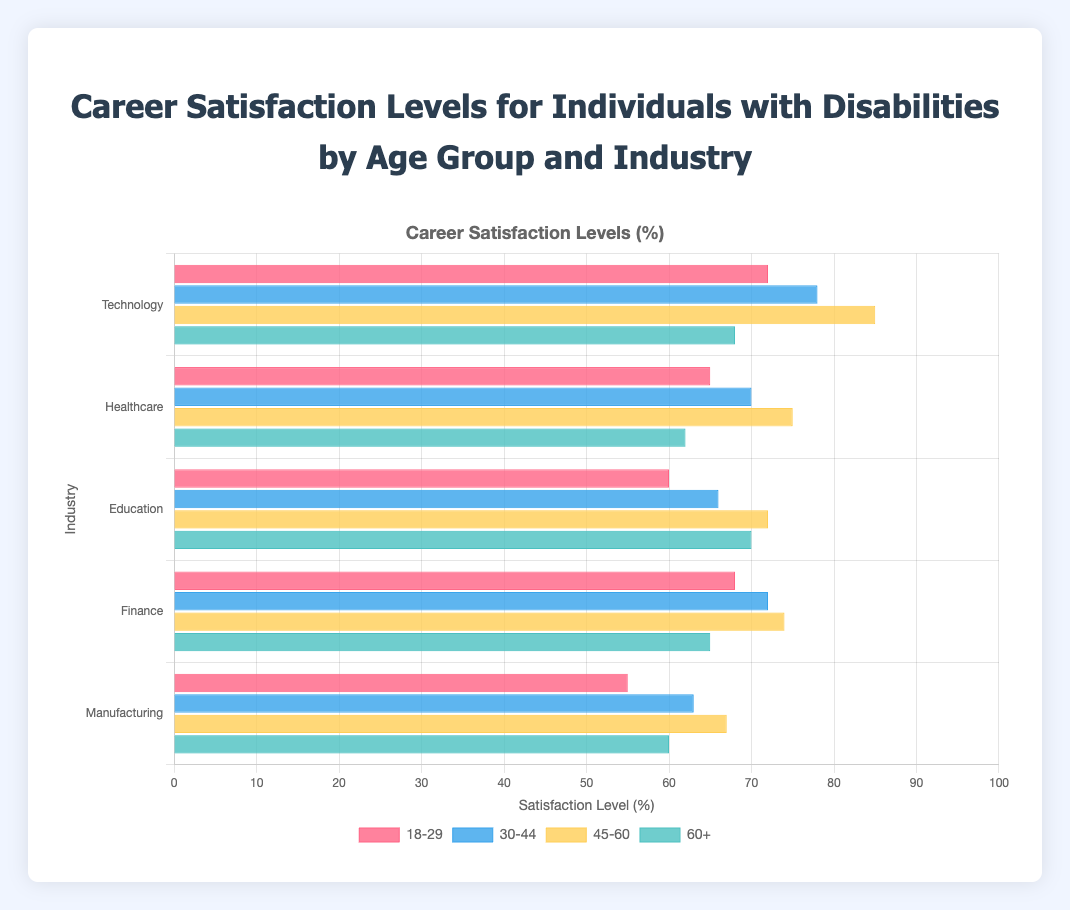Which industry has the highest career satisfaction for the age group 45-60? The bar corresponding to the 45-60 age group for the Technology industry is the tallest, showing the highest satisfaction at 85.
Answer: Technology Comparing the age groups 18-29 and 30-44, which one has higher satisfaction in the Healthcare industry? The bar for the 30-44 age group in Healthcare reaches 70, while the bar for the 18-29 age group is at 65.
Answer: 30-44 What is the average career satisfaction across all industries for the age group 60+? Add the satisfaction levels for age group 60+ in all industries: (68 + 62 + 70 + 65 + 60) = 325. Divide by the number of industries, 5: 325 / 5 = 65
Answer: 65 Which industry shows the lowest career satisfaction for the age group 18-29? The bar for the Manufacturing industry for the age group 18-29 is the shortest, showing satisfaction at 55.
Answer: Manufacturing Is there any industry where the 18-29 age group has higher satisfaction than the 45-60 age group? By comparing bars for the 18-29 age group and the 45-60 age group across all industries, in no industry the 18-29 age group has a higher satisfaction than the 45-60 age group.
Answer: No What is the difference in career satisfaction between the 30-44 and 60+ age groups in the Education industry? The satisfaction for 30-44 in Education is 66, and for 60+ it is 70. The difference is 70 - 66 = 4.
Answer: 4 Which age group has the highest career satisfaction in the Finance industry? The tallest bar for Finance is for the 45-60 age group with a satisfaction level of 74.
Answer: 45-60 How does satisfaction in Manufacturing compare to Finance for the 30-44 age group? The satisfaction level for Manufacturing is 63, while for Finance it is 72; 72 is greater than 63.
Answer: Finance is higher By how much does the satisfaction level for the 45-60 age group in Technology exceed the same age group in Manufacturing? The satisfaction level in Technology for 45-60 is 85, and in Manufacturing it is 67. The difference is 85 - 67 = 18.
Answer: 18 Which age group shows the color red in the bar chart? The color red in the bar chart corresponds to the 18-29 age group.
Answer: 18-29 